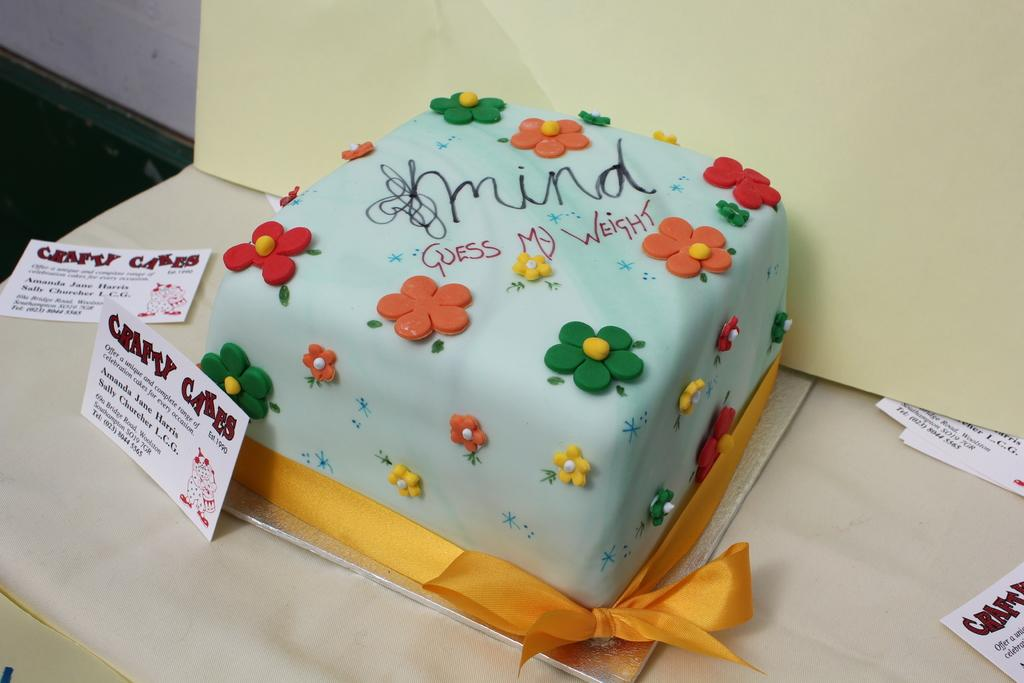What is the main food item visible in the image? There is a cake in the image. What else can be seen on the table in the image? There are papers on the table in the image. What type of leather material can be seen on the cake in the image? There is no leather material present on the cake in the image. Where is the nearest playground to the location of the image? The provided facts do not give any information about the location of the image, so it is impossible to determine the nearest playground. 